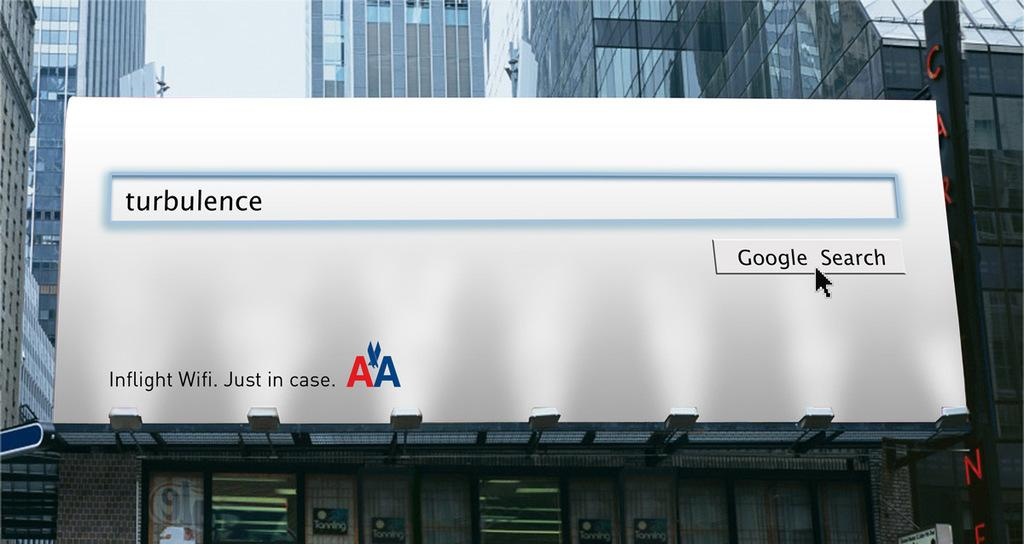<image>
Describe the image concisely. and ad showing AA having in flight wifi 